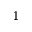<formula> <loc_0><loc_0><loc_500><loc_500>^ { 1 }</formula> 